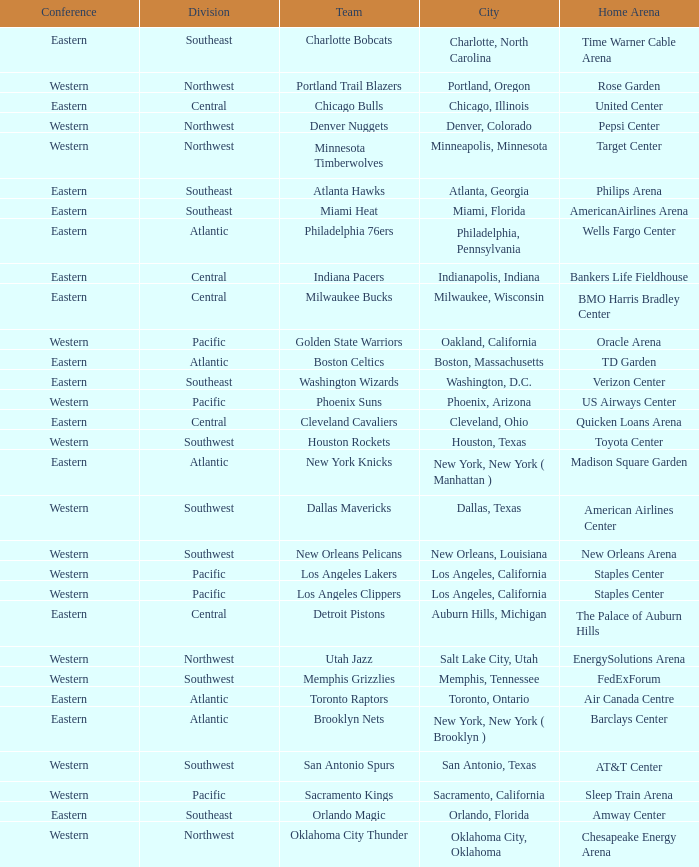Which city includes the Target Center arena? Minneapolis, Minnesota. 